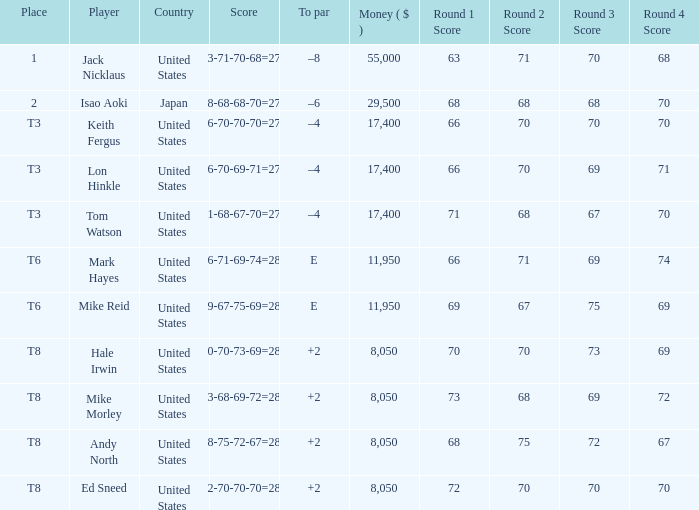What country has the score og 66-70-69-71=276? United States. 